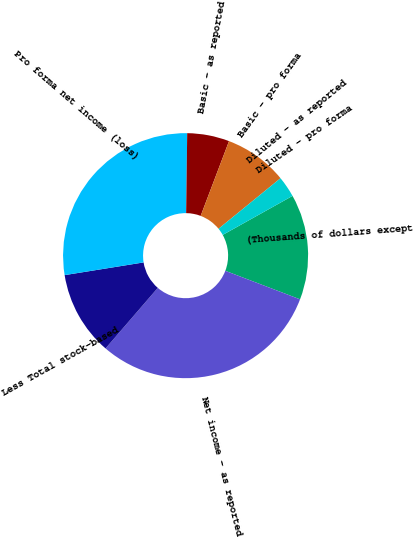Convert chart to OTSL. <chart><loc_0><loc_0><loc_500><loc_500><pie_chart><fcel>(Thousands of dollars except<fcel>Net income - as reported<fcel>Less Total stock-based<fcel>Pro forma net income (loss)<fcel>Basic - as reported<fcel>Basic - pro forma<fcel>Diluted - as reported<fcel>Diluted - pro forma<nl><fcel>13.91%<fcel>30.53%<fcel>11.13%<fcel>27.75%<fcel>5.56%<fcel>8.34%<fcel>0.0%<fcel>2.78%<nl></chart> 